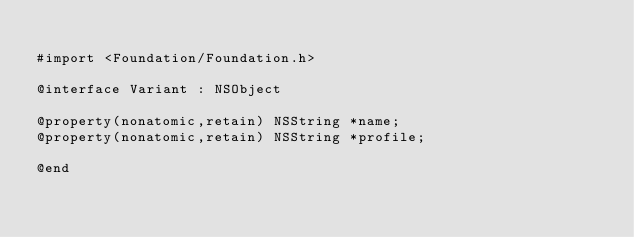Convert code to text. <code><loc_0><loc_0><loc_500><loc_500><_C_>
#import <Foundation/Foundation.h>

@interface Variant : NSObject

@property(nonatomic,retain) NSString *name;
@property(nonatomic,retain) NSString *profile;

@end
</code> 